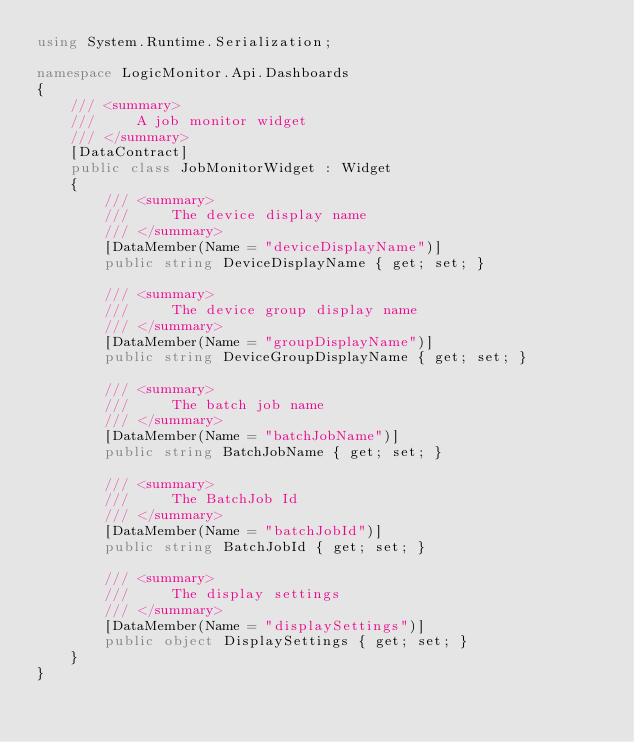<code> <loc_0><loc_0><loc_500><loc_500><_C#_>using System.Runtime.Serialization;

namespace LogicMonitor.Api.Dashboards
{
	/// <summary>
	///     A job monitor widget
	/// </summary>
	[DataContract]
	public class JobMonitorWidget : Widget
	{
		/// <summary>
		///     The device display name
		/// </summary>
		[DataMember(Name = "deviceDisplayName")]
		public string DeviceDisplayName { get; set; }

		/// <summary>
		///     The device group display name
		/// </summary>
		[DataMember(Name = "groupDisplayName")]
		public string DeviceGroupDisplayName { get; set; }

		/// <summary>
		///     The batch job name
		/// </summary>
		[DataMember(Name = "batchJobName")]
		public string BatchJobName { get; set; }

		/// <summary>
		///     The BatchJob Id
		/// </summary>
		[DataMember(Name = "batchJobId")]
		public string BatchJobId { get; set; }

		/// <summary>
		///     The display settings
		/// </summary>
		[DataMember(Name = "displaySettings")]
		public object DisplaySettings { get; set; }
	}
}</code> 